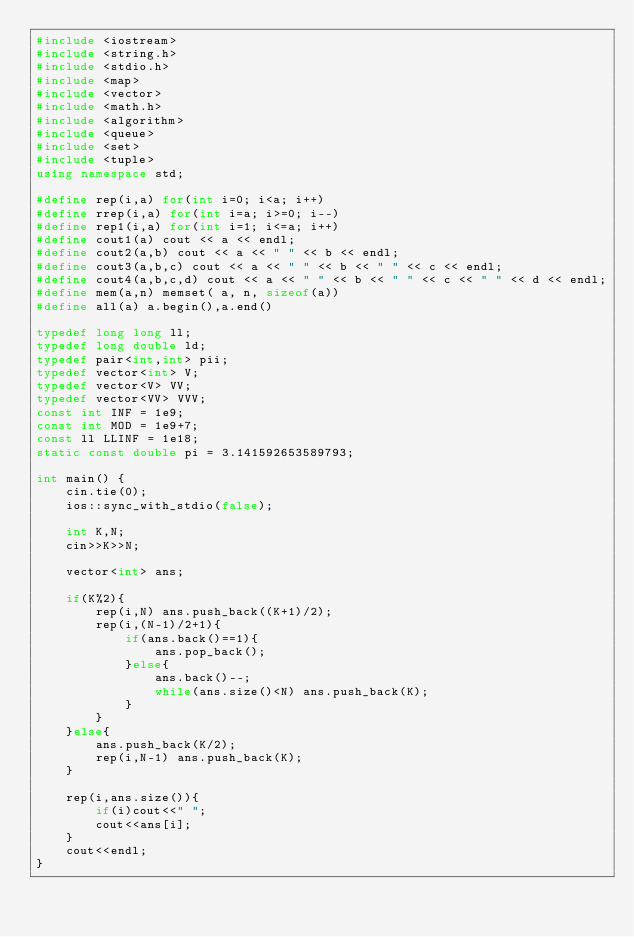<code> <loc_0><loc_0><loc_500><loc_500><_C++_>#include <iostream>
#include <string.h>
#include <stdio.h>
#include <map>
#include <vector>
#include <math.h>
#include <algorithm>
#include <queue>
#include <set>
#include <tuple>
using namespace std;

#define rep(i,a) for(int i=0; i<a; i++)
#define rrep(i,a) for(int i=a; i>=0; i--)
#define rep1(i,a) for(int i=1; i<=a; i++)
#define cout1(a) cout << a << endl;
#define cout2(a,b) cout << a << " " << b << endl;
#define cout3(a,b,c) cout << a << " " << b << " " << c << endl;
#define cout4(a,b,c,d) cout << a << " " << b << " " << c << " " << d << endl;
#define mem(a,n) memset( a, n, sizeof(a))
#define all(a) a.begin(),a.end()

typedef long long ll;
typedef long double ld;
typedef pair<int,int> pii;
typedef vector<int> V;
typedef vector<V> VV;
typedef vector<VV> VVV;
const int INF = 1e9;
const int MOD = 1e9+7;
const ll LLINF = 1e18;
static const double pi = 3.141592653589793;

int main() {
    cin.tie(0);
    ios::sync_with_stdio(false);
    
    int K,N;
    cin>>K>>N;
    
    vector<int> ans;
    
    if(K%2){
        rep(i,N) ans.push_back((K+1)/2);
        rep(i,(N-1)/2+1){
            if(ans.back()==1){
                ans.pop_back();
            }else{
                ans.back()--;
                while(ans.size()<N) ans.push_back(K);
            }
        }
    }else{
        ans.push_back(K/2);
        rep(i,N-1) ans.push_back(K);
    }
    
    rep(i,ans.size()){
        if(i)cout<<" ";
        cout<<ans[i];
    }
    cout<<endl;
}</code> 